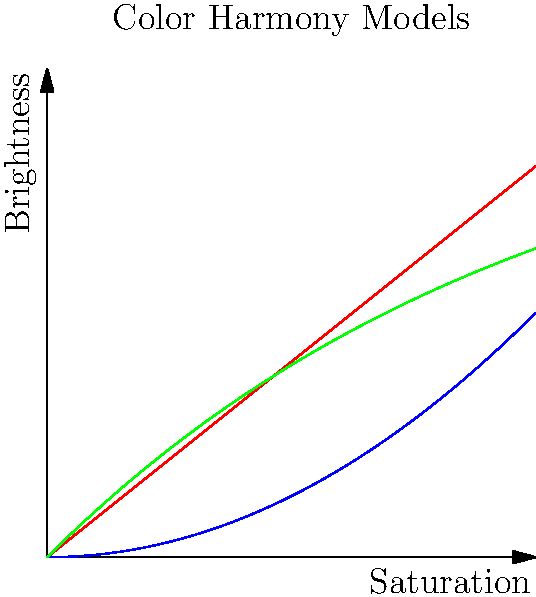In developing a color theory-based recommendation system for digital product design, you're tasked with implementing different color harmony models. The graph shows three potential models for relating saturation to brightness in harmonious color schemes. Which model would be most suitable for creating a dynamic, engaging user interface that maintains readability across various screen sizes and resolutions? To answer this question, we need to consider the characteristics of each model and their implications for user interface design:

1. Linear model (red line):
   - Represents a constant ratio between saturation and brightness
   - Pros: Simple and predictable
   - Cons: May lack visual interest and fail to accommodate for human perception

2. Quadratic model (blue curve):
   - Represents a non-linear relationship where brightness increases more rapidly at higher saturation levels
   - Pros: Provides more contrast at higher saturation levels
   - Cons: May result in overly bright colors at high saturation, potentially compromising readability

3. Exponential model (green curve):
   - Represents a relationship where brightness increases rapidly at low saturation levels and then levels off
   - Pros:
     a) Maintains good readability at both low and high saturation levels
     b) Mimics human perception of color more closely
     c) Provides a balance between visual interest and functionality
   - Cons: Slightly more complex to implement than the linear model

For a dynamic, engaging user interface that maintains readability across various screen sizes and resolutions, the exponential model (green curve) would be most suitable because:

1. It provides a good balance between saturation and brightness, ensuring that colors remain visually appealing without compromising readability.
2. The rapid increase in brightness at low saturation levels helps maintain contrast and legibility for smaller UI elements or on lower resolution screens.
3. The leveling off of brightness at higher saturation levels prevents colors from becoming too intense or overwhelming, which is particularly important for larger UI elements or high-resolution displays.
4. The non-linear nature of the model adds visual interest and depth to the color palette, contributing to a more engaging user experience.
5. It more closely aligns with human color perception, potentially leading to a more intuitive and comfortable user experience.
Answer: Exponential model 